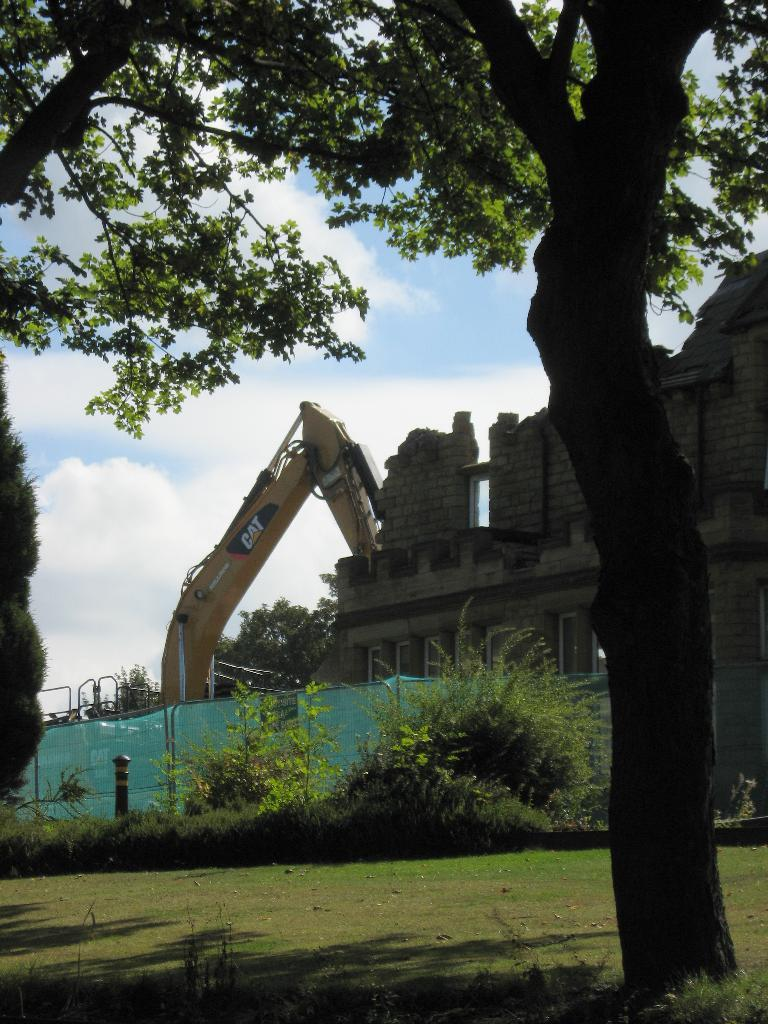What type of structure is present in the image? There is a house in the image. What can be seen in the background of the image? There are many trees and plants in the image, as well as a grassy land. What else is visible in the image? There is a vehicle and a sky visible in the image. What type of ear is visible in the image? There is no ear present in the image. What type of canvas is used to create the image? The image is not a painting or drawing, so there is no canvas used to create it. 